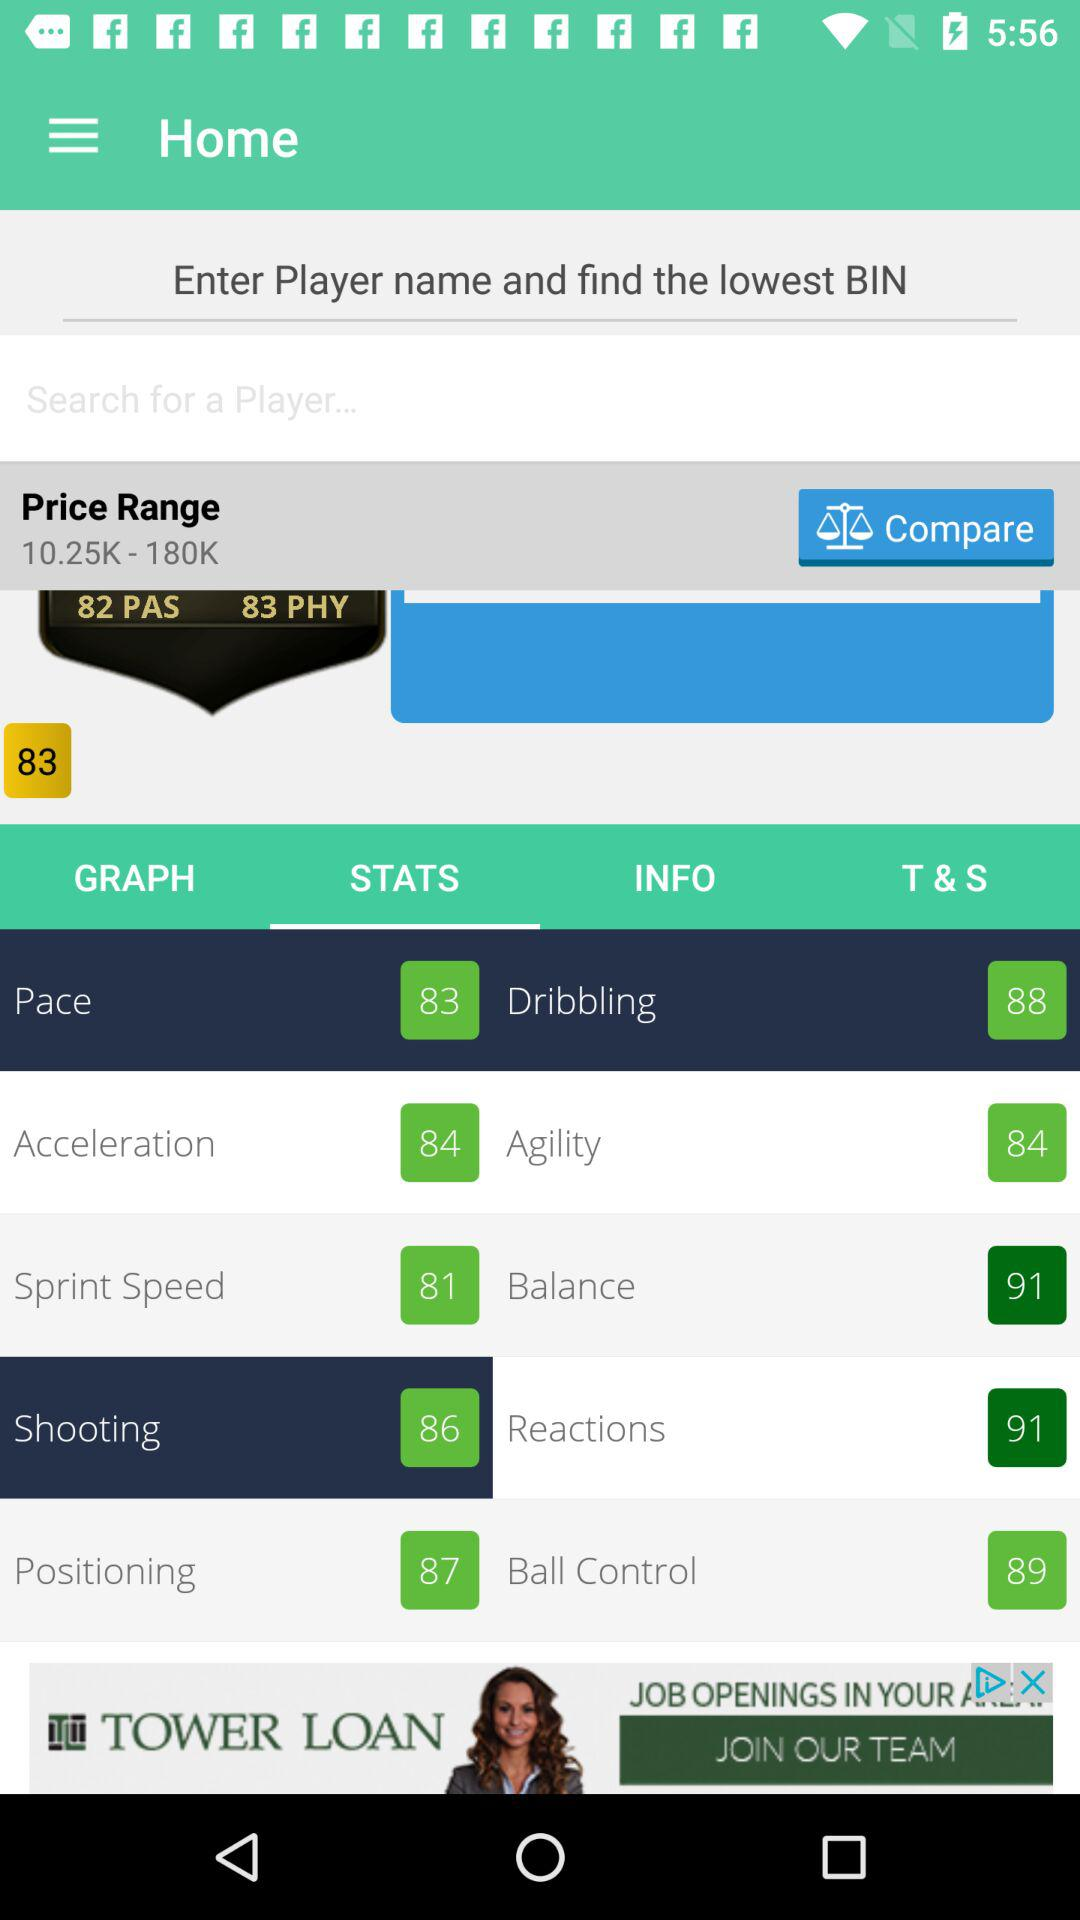What is the difference between the player's pace and dribbling stats?
Answer the question using a single word or phrase. 5 